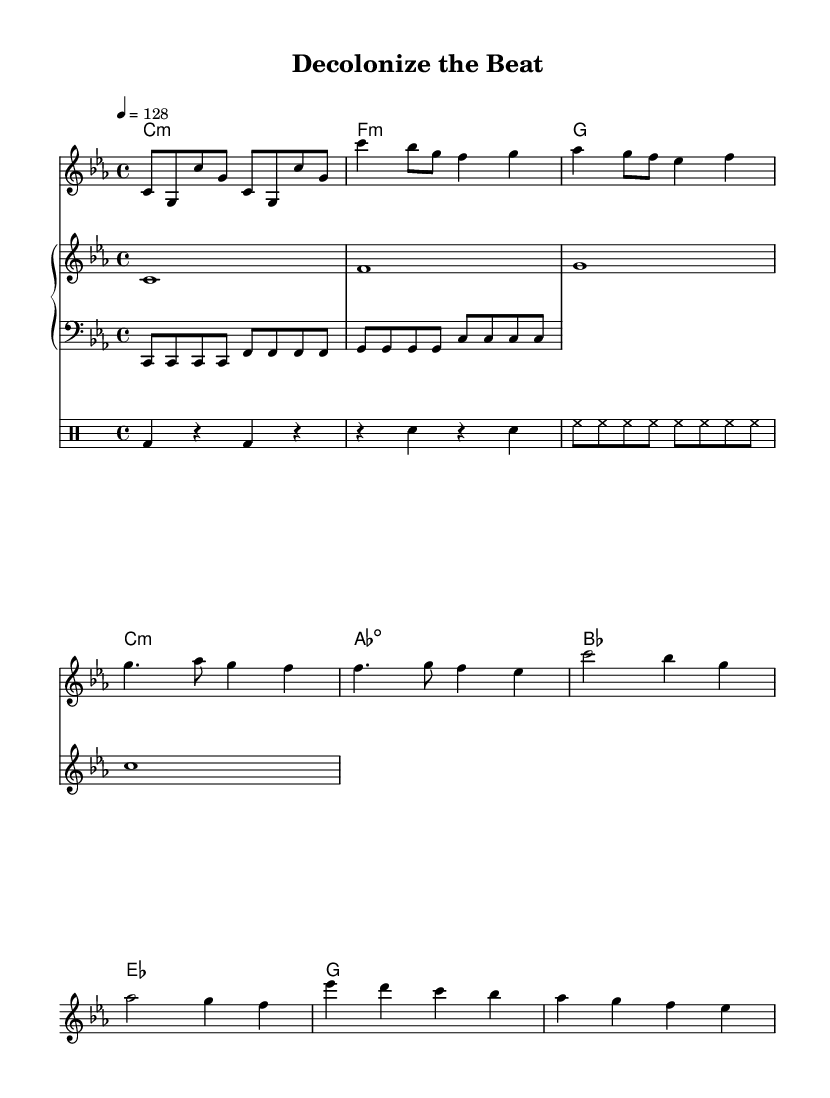What is the key signature of this music? The key signature is indicated at the beginning of the score, showing C minor which has three flats (B♭, E♭, and A♭).
Answer: C minor What is the time signature of this music? The time signature is found at the start of the score, indicated as 4/4, meaning there are four beats per measure.
Answer: 4/4 What is the tempo marking for this dance music? The tempo marking is located above the melody section, showing the speed of the piece at 128 beats per minute.
Answer: 128 How many measures are in the verse section? By counting the individual measures under the verse in the score, we find there are four measures in total dedicated to the verse.
Answer: 4 What is the first note of the chorus? Looking at the melody, the first note of the chorus is indicated as a C, which is noted in the sheet music.
Answer: C What rhythmic figure is used in the drum pattern? The rhythmic pattern in the drum section shows the use of quarter notes and eighth notes to create a typical driving beat found in electronic dance music.
Answer: Eighth notes and quarter notes How are the lyrics related to the theme of the music? The lyrics explicitly address themes of social justice and post-colonialism, with phrases discussing breaking chains of oppression and claiming history, aligning with the activism focus of the piece.
Answer: Social justice and post-colonialism 